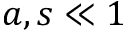<formula> <loc_0><loc_0><loc_500><loc_500>a , s \ll 1</formula> 